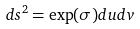Convert formula to latex. <formula><loc_0><loc_0><loc_500><loc_500>d s ^ { 2 } = \exp ( \sigma ) d u d v</formula> 